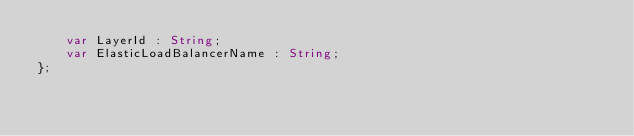Convert code to text. <code><loc_0><loc_0><loc_500><loc_500><_Haxe_>    var LayerId : String;
    var ElasticLoadBalancerName : String;
};
</code> 